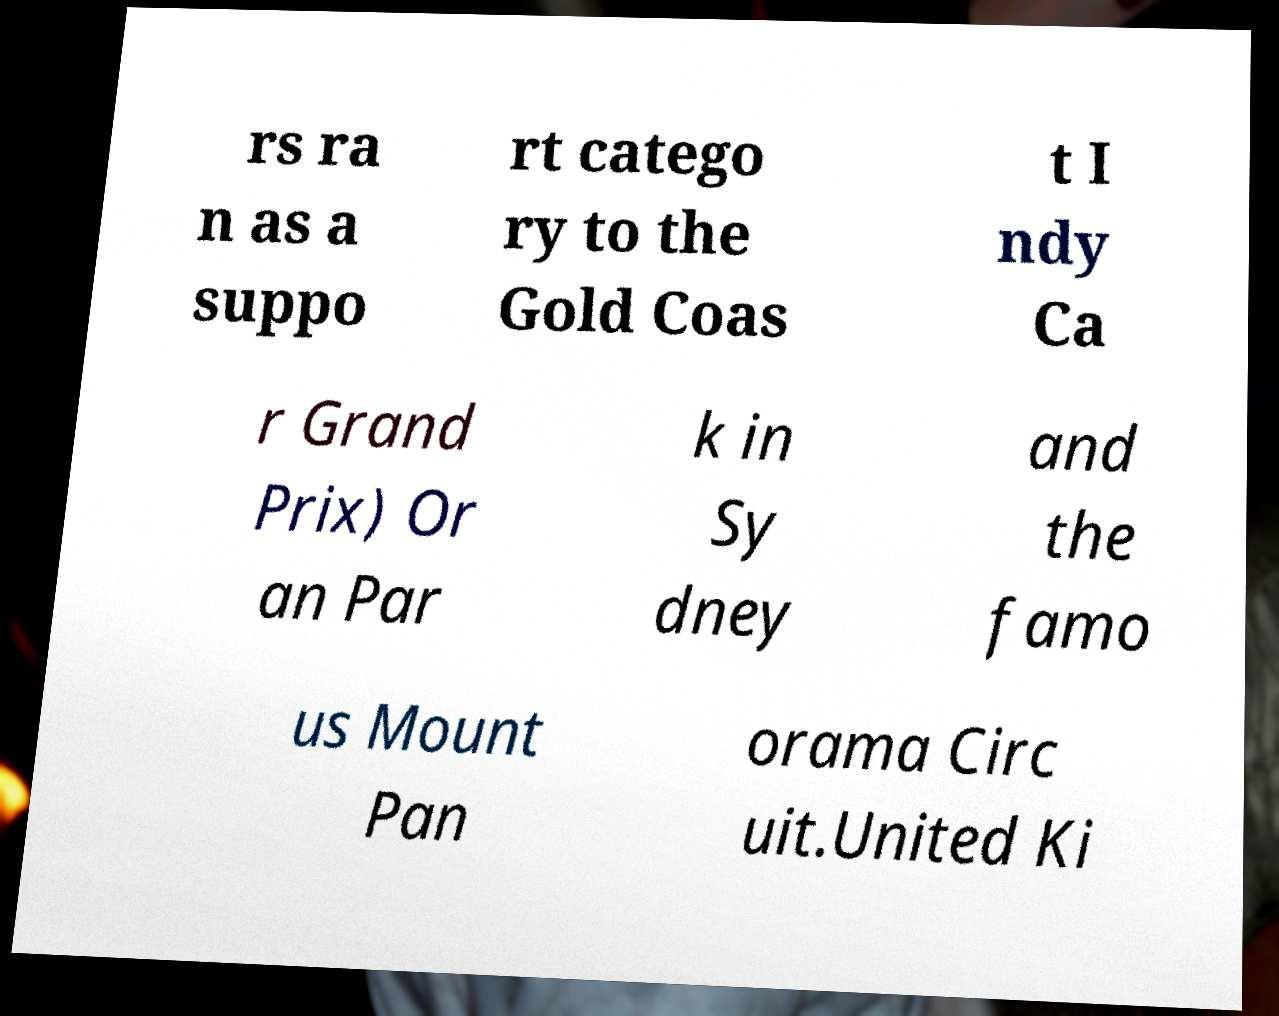Can you read and provide the text displayed in the image?This photo seems to have some interesting text. Can you extract and type it out for me? rs ra n as a suppo rt catego ry to the Gold Coas t I ndy Ca r Grand Prix) Or an Par k in Sy dney and the famo us Mount Pan orama Circ uit.United Ki 